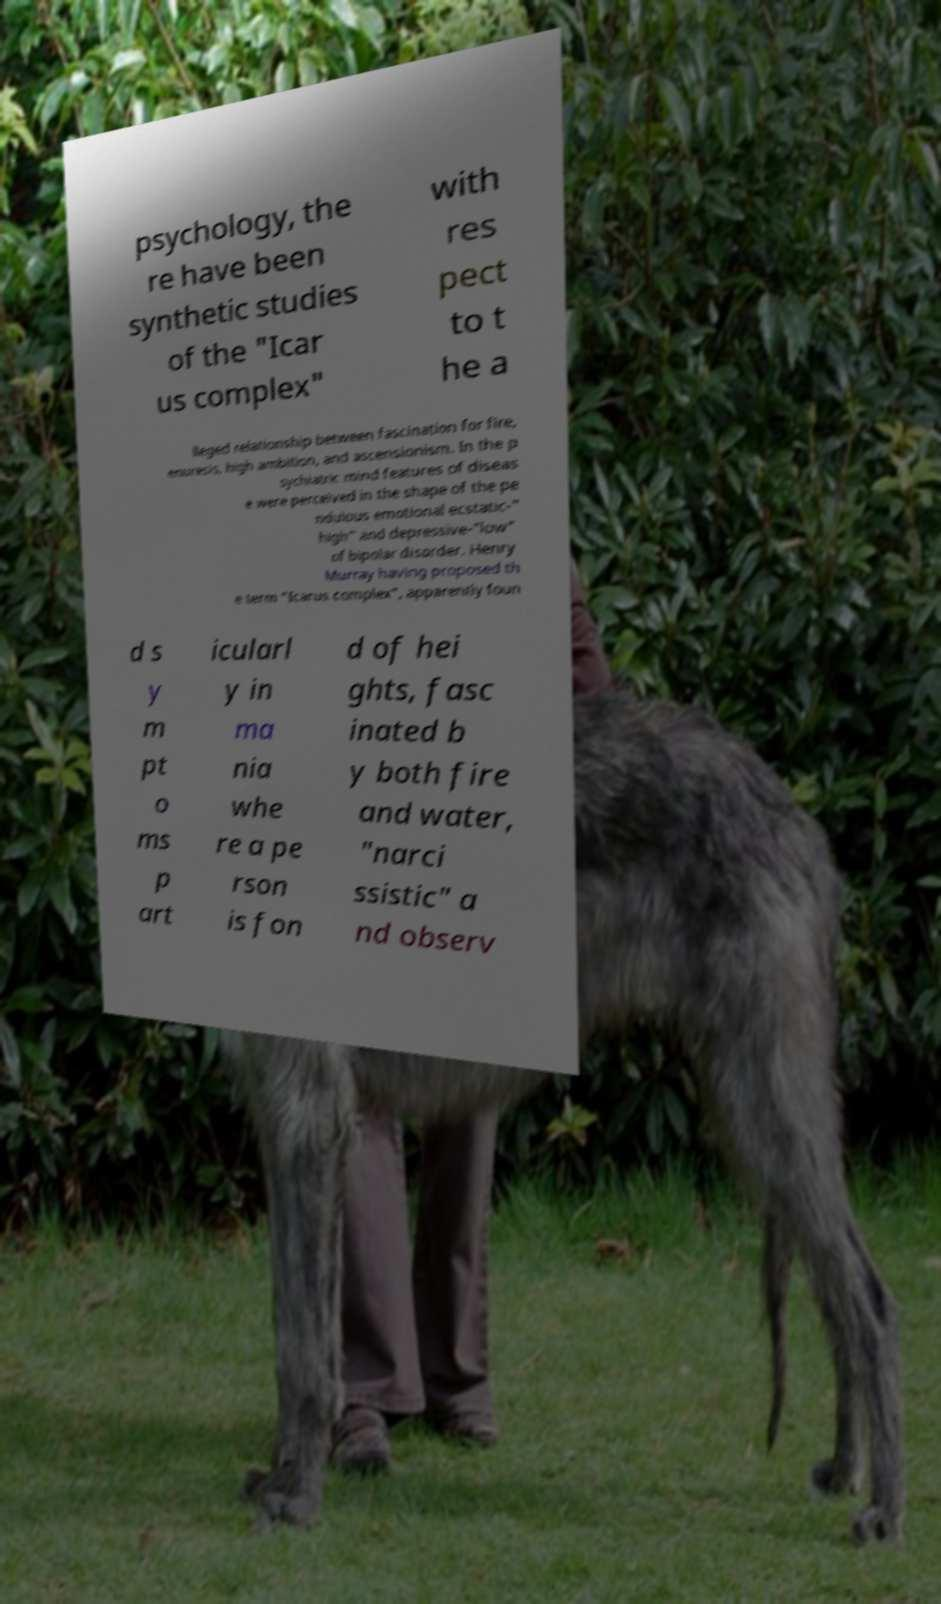I need the written content from this picture converted into text. Can you do that? psychology, the re have been synthetic studies of the "Icar us complex" with res pect to t he a lleged relationship between fascination for fire, enuresis, high ambition, and ascensionism. In the p sychiatric mind features of diseas e were perceived in the shape of the pe ndulous emotional ecstatic-" high" and depressive-"low" of bipolar disorder. Henry Murray having proposed th e term "Icarus complex", apparently foun d s y m pt o ms p art icularl y in ma nia whe re a pe rson is fon d of hei ghts, fasc inated b y both fire and water, "narci ssistic" a nd observ 